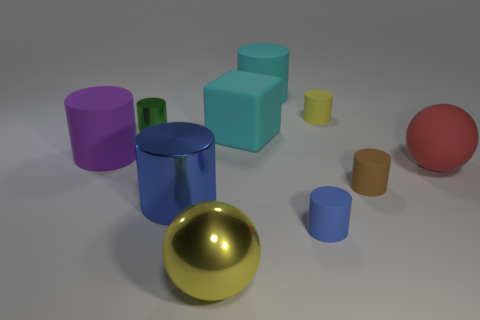There is a tiny object to the left of the big block; is there a shiny cylinder to the right of it?
Offer a very short reply. Yes. How many other objects are the same color as the large rubber block?
Offer a very short reply. 1. What size is the purple rubber cylinder?
Your answer should be very brief. Large. Are any yellow cylinders visible?
Offer a terse response. Yes. Are there more large cyan rubber things in front of the tiny green thing than red matte spheres behind the red rubber sphere?
Provide a succinct answer. Yes. What is the material of the small object that is in front of the tiny yellow object and to the right of the tiny blue rubber object?
Provide a short and direct response. Rubber. Does the purple rubber object have the same shape as the yellow metal thing?
Your response must be concise. No. There is a green shiny thing; what number of big cyan matte objects are behind it?
Give a very brief answer. 1. There is a yellow object behind the rubber block; is its size the same as the green metallic cylinder?
Offer a very short reply. Yes. There is another object that is the same shape as the red rubber object; what is its color?
Offer a very short reply. Yellow. 